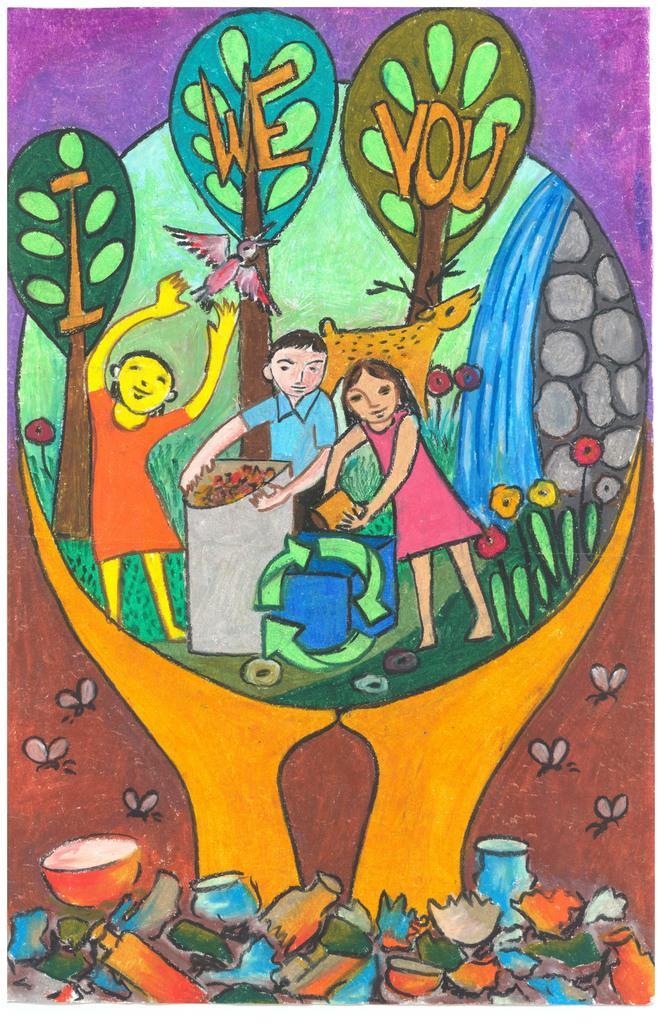Could you give a brief overview of what you see in this image? In this image there is a painting. In this painting we can see children, recycle bin and trees. In the center there is a bird and an animal. We can see waterfall, grass and flowers. At the bottom there are flies and broken vessels. There is a bowl and a vase. In the background there is text and trees. 